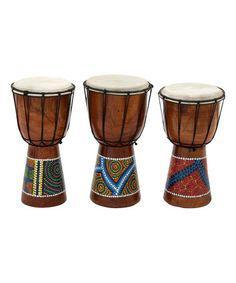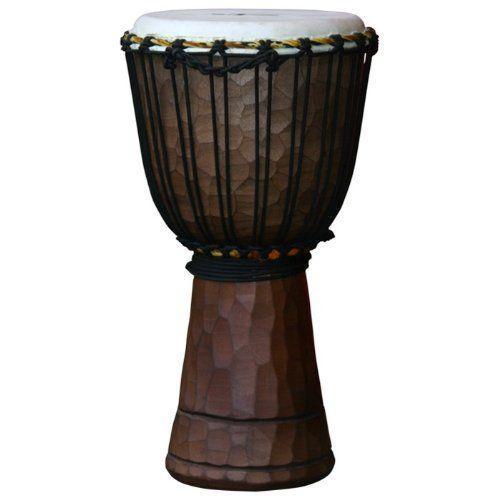The first image is the image on the left, the second image is the image on the right. Examine the images to the left and right. Is the description "The left image contains a neat row of three brown drums, and the right image features a single upright brown drum." accurate? Answer yes or no. Yes. The first image is the image on the left, the second image is the image on the right. Given the left and right images, does the statement "One image shows a set of three congas and the other shows a single conga drum." hold true? Answer yes or no. Yes. 